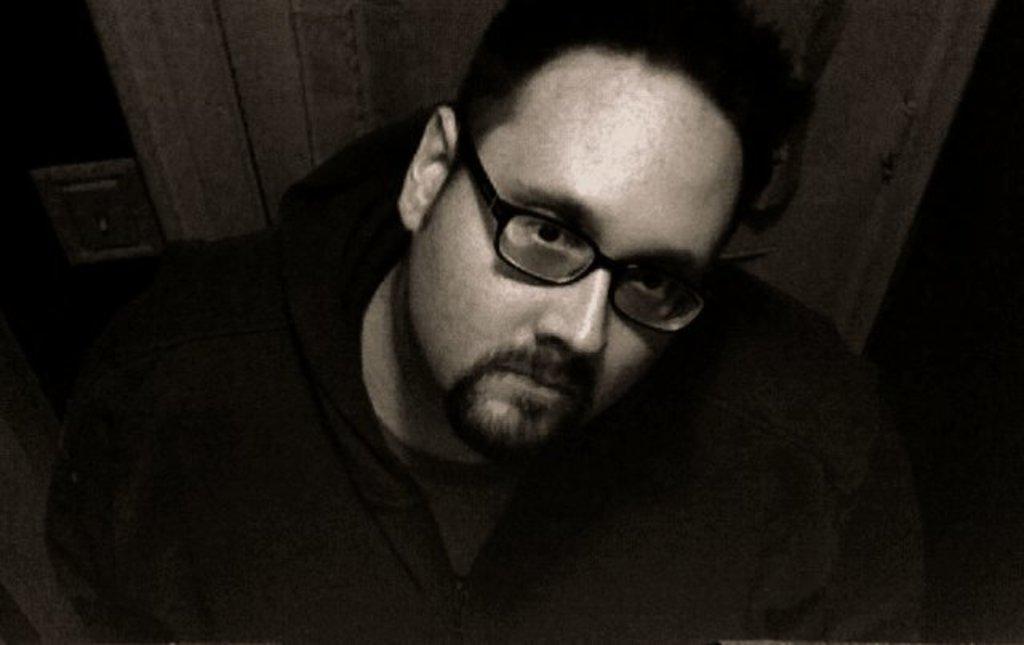In one or two sentences, can you explain what this image depicts? It is a black and white image. In this image we can see a person wearing the glasses and the background is not clear. 